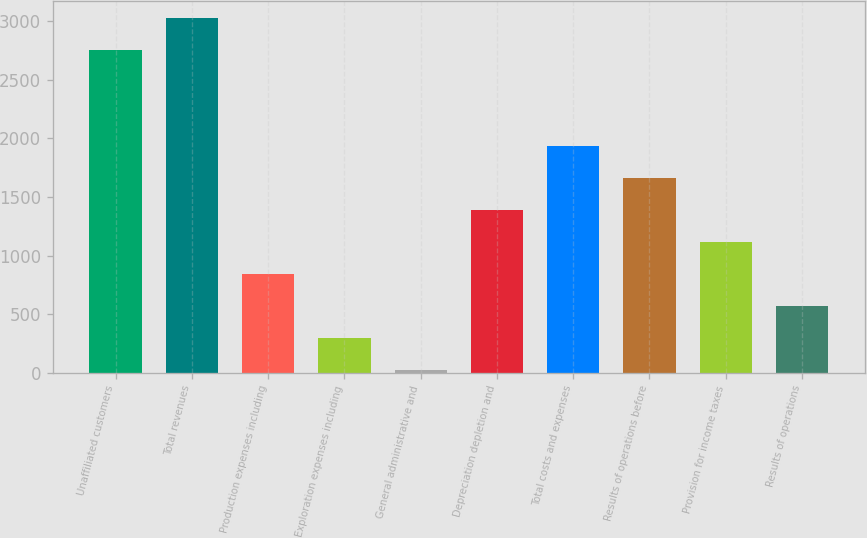<chart> <loc_0><loc_0><loc_500><loc_500><bar_chart><fcel>Unaffiliated customers<fcel>Total revenues<fcel>Production expenses including<fcel>Exploration expenses including<fcel>General administrative and<fcel>Depreciation depletion and<fcel>Total costs and expenses<fcel>Results of operations before<fcel>Provision for income taxes<fcel>Results of operations<nl><fcel>2750<fcel>3023<fcel>839<fcel>293<fcel>20<fcel>1385<fcel>1931<fcel>1658<fcel>1112<fcel>566<nl></chart> 